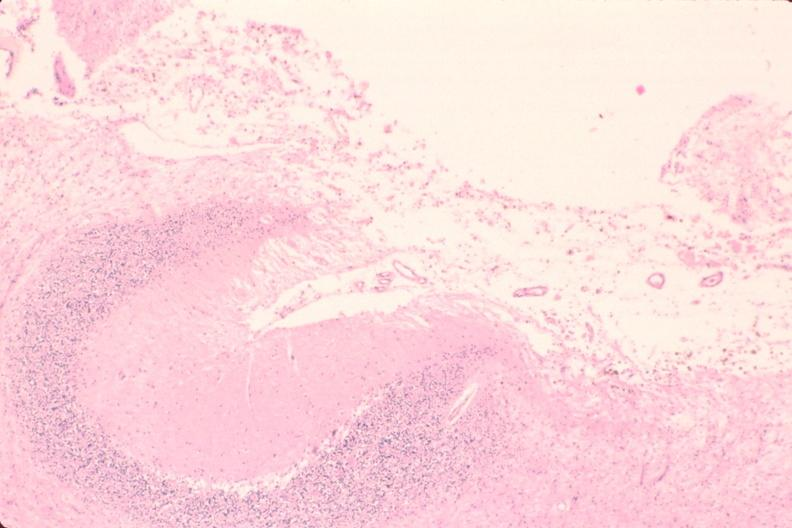s pneumocystis present?
Answer the question using a single word or phrase. No 